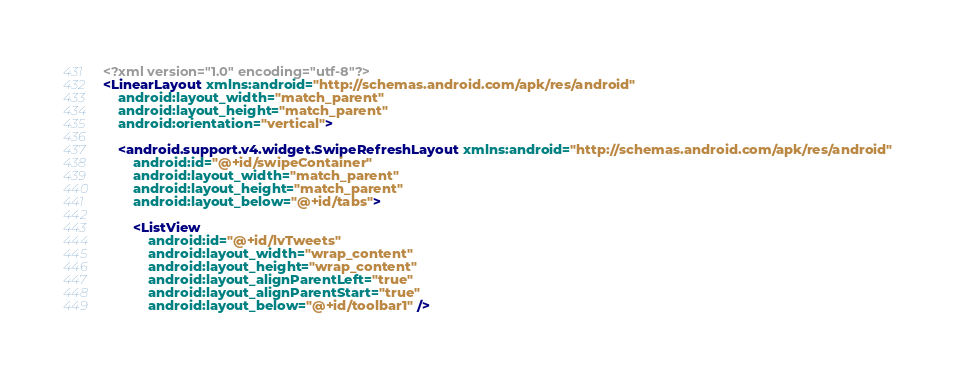<code> <loc_0><loc_0><loc_500><loc_500><_XML_><?xml version="1.0" encoding="utf-8"?>
<LinearLayout xmlns:android="http://schemas.android.com/apk/res/android"
    android:layout_width="match_parent"
    android:layout_height="match_parent"
    android:orientation="vertical">

    <android.support.v4.widget.SwipeRefreshLayout xmlns:android="http://schemas.android.com/apk/res/android"
        android:id="@+id/swipeContainer"
        android:layout_width="match_parent"
        android:layout_height="match_parent"
        android:layout_below="@+id/tabs">

        <ListView
            android:id="@+id/lvTweets"
            android:layout_width="wrap_content"
            android:layout_height="wrap_content"
            android:layout_alignParentLeft="true"
            android:layout_alignParentStart="true"
            android:layout_below="@+id/toolbar1" />
</code> 